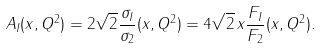Convert formula to latex. <formula><loc_0><loc_0><loc_500><loc_500>A _ { I } ( x , Q ^ { 2 } ) = 2 \sqrt { 2 } \frac { { } \sigma _ { I } } { \sigma _ { 2 } } ( x , Q ^ { 2 } ) = 4 \sqrt { 2 } \, x \frac { F _ { I } } { F _ { 2 } } ( x , Q ^ { 2 } ) .</formula> 